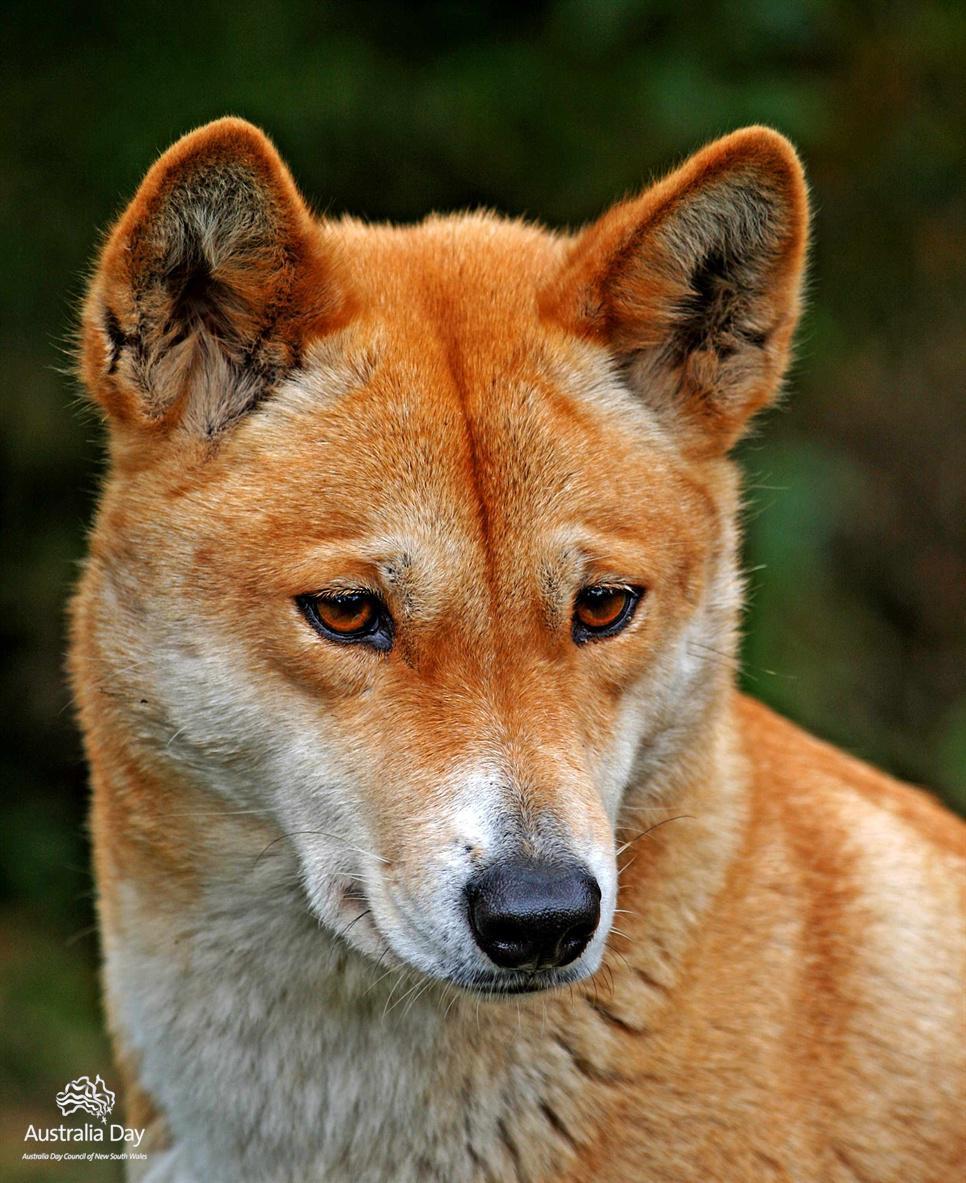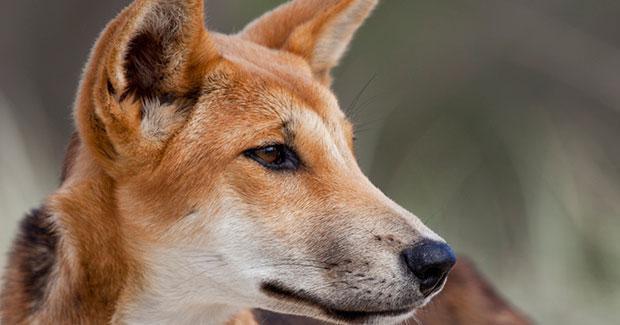The first image is the image on the left, the second image is the image on the right. Examine the images to the left and right. Is the description "There are two dogs, and neither of them is looking to the left." accurate? Answer yes or no. Yes. The first image is the image on the left, the second image is the image on the right. For the images displayed, is the sentence "The dog in the left image stands on a rock, body in profile turned rightward." factually correct? Answer yes or no. No. 